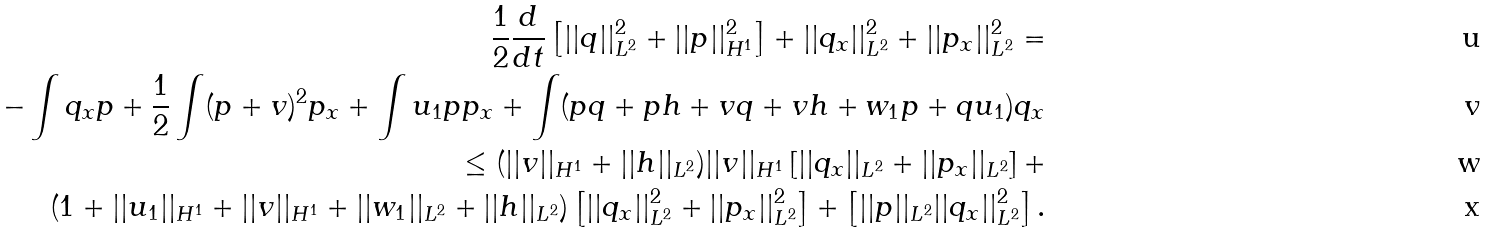<formula> <loc_0><loc_0><loc_500><loc_500>\frac { 1 } { 2 } \frac { d } { d t } \left [ | | q | | _ { L ^ { 2 } } ^ { 2 } + | | p | | _ { H ^ { 1 } } ^ { 2 } \right ] + | | q _ { x } | | _ { L ^ { 2 } } ^ { 2 } + | | p _ { x } | | _ { L ^ { 2 } } ^ { 2 } = \\ - \int q _ { x } p + \frac { 1 } { 2 } \int ( p + v ) ^ { 2 } p _ { x } + \int u _ { 1 } p p _ { x } + \int ( p q + p h + v q + v h + w _ { 1 } p + q u _ { 1 } ) q _ { x } \\ \leq ( | | v | | _ { H ^ { 1 } } + | | h | | _ { L ^ { 2 } } ) | | v | | _ { H ^ { 1 } } \left [ | | q _ { x } | | _ { L ^ { 2 } } + | | p _ { x } | | _ { L ^ { 2 } } \right ] + \\ ( 1 + | | u _ { 1 } | | _ { H ^ { 1 } } + | | v | | _ { H ^ { 1 } } + | | w _ { 1 } | | _ { L ^ { 2 } } + | | h | | _ { L ^ { 2 } } ) \left [ | | q _ { x } | | _ { L ^ { 2 } } ^ { 2 } + | | p _ { x } | | _ { L ^ { 2 } } ^ { 2 } \right ] + \left [ | | p | | _ { L ^ { 2 } } | | q _ { x } | | _ { L ^ { 2 } } ^ { 2 } \right ] .</formula> 